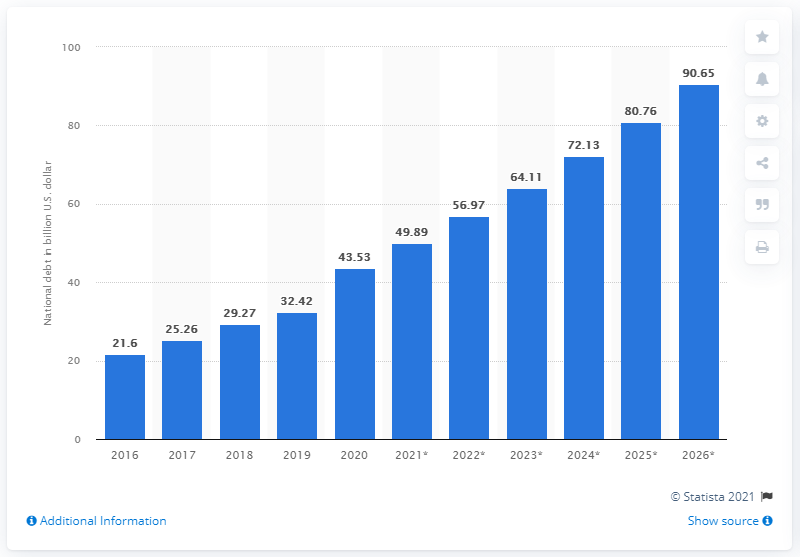Mention a couple of crucial points in this snapshot. In 2020, the national debt of Kazakhstan was approximately 43.53 dollars. 